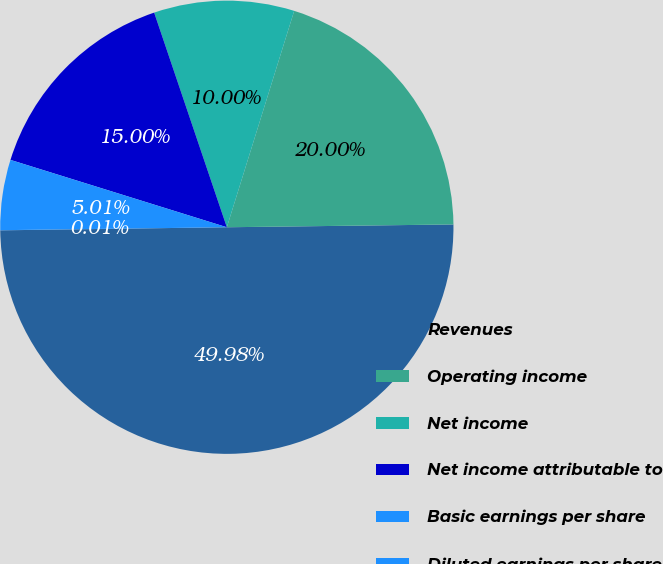Convert chart to OTSL. <chart><loc_0><loc_0><loc_500><loc_500><pie_chart><fcel>Revenues<fcel>Operating income<fcel>Net income<fcel>Net income attributable to<fcel>Basic earnings per share<fcel>Diluted earnings per share<nl><fcel>49.98%<fcel>20.0%<fcel>10.0%<fcel>15.0%<fcel>5.01%<fcel>0.01%<nl></chart> 